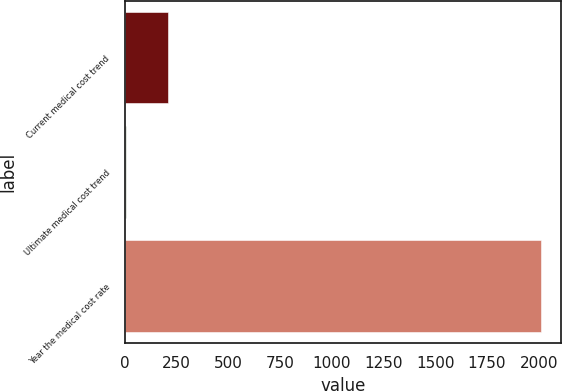<chart> <loc_0><loc_0><loc_500><loc_500><bar_chart><fcel>Current medical cost trend<fcel>Ultimate medical cost trend<fcel>Year the medical cost rate<nl><fcel>205.95<fcel>5.5<fcel>2010<nl></chart> 